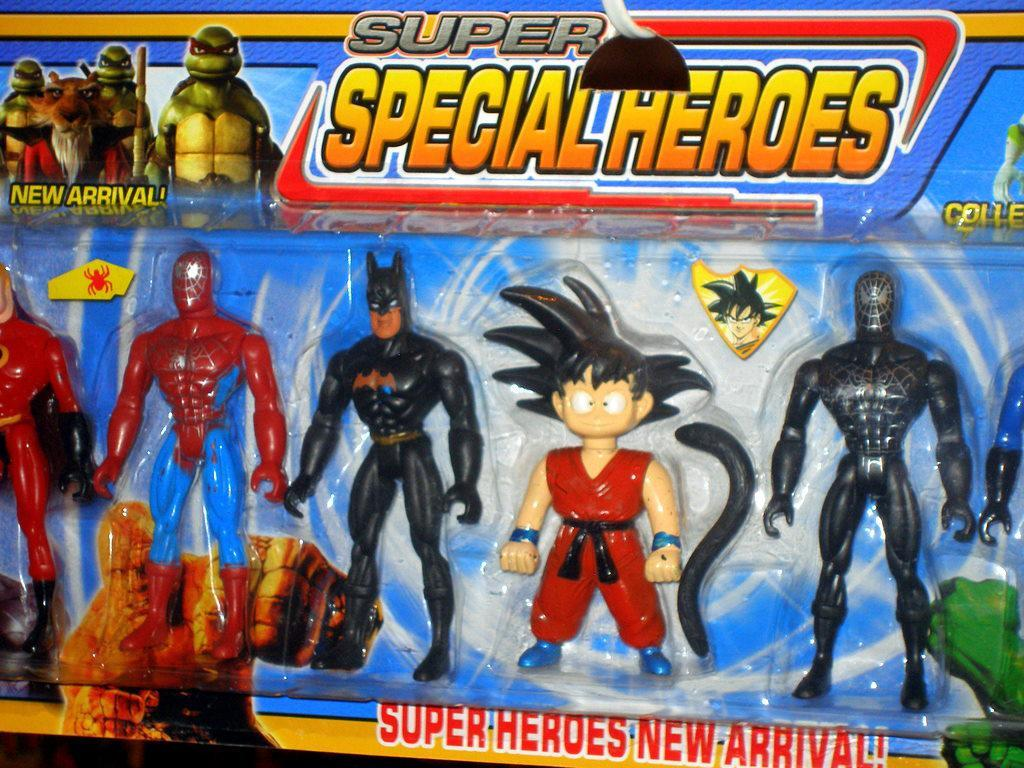<image>
Relay a brief, clear account of the picture shown. a box of super special heroes that says 'super heroes new arrival!' 